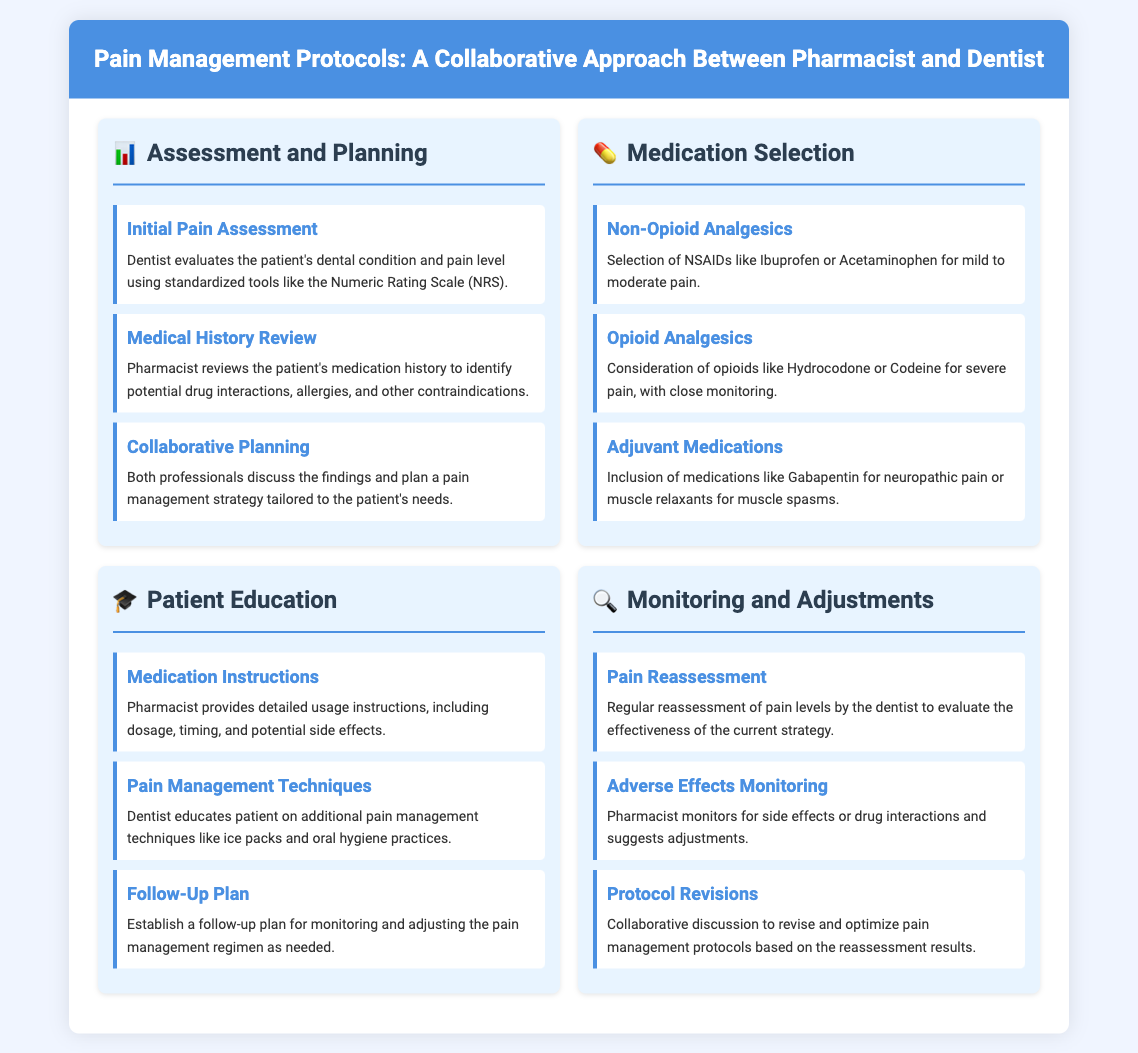what is the first step in the pain management protocol? The first step is the Initial Pain Assessment, where the dentist evaluates the patient's dental condition and pain level.
Answer: Initial Pain Assessment what medication is selected for mild to moderate pain? The document specifies Non-Opioid Analgesics, particularly NSAIDs like Ibuprofen or Acetaminophen.
Answer: NSAIDs like Ibuprofen or Acetaminophen who monitors for side effects or drug interactions? The pharmacist is responsible for monitoring side effects or drug interactions during the pain management process.
Answer: Pharmacist what should the pharmacist provide to the patient? The pharmacist should provide detailed usage instructions, including dosage, timing, and potential side effects.
Answer: Detailed usage instructions which section focuses on patient education? The section that focuses on patient education is titled "Patient Education."
Answer: Patient Education what type of analgesics is considered for severe pain? The document states that Opioid Analgesics such as Hydrocodone or Codeine are considered for severe pain.
Answer: Opioid Analgesics how often should pain levels be reassessed? The document does not specify an exact frequency, but it indicates that regular reassessment should occur.
Answer: Regularly what is the goal of the collaborative planning step? The goal is to plan a pain management strategy tailored to the patient's needs based on the findings discussed.
Answer: Tailored pain management strategy what technique does the dentist educate the patient on? The dentist educates the patient on pain management techniques like ice packs and oral hygiene practices.
Answer: Ice packs and oral hygiene practices 